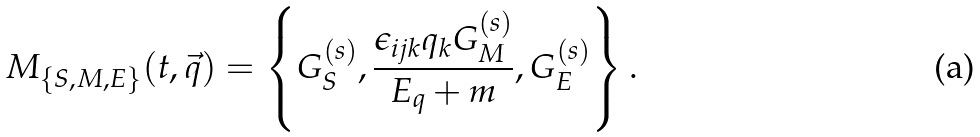Convert formula to latex. <formula><loc_0><loc_0><loc_500><loc_500>M _ { \{ S , M , E \} } ( t , \vec { q } ) = \left \{ G _ { S } ^ { ( s ) } , \frac { \epsilon _ { i j k } q _ { k } G _ { M } ^ { ( s ) } } { E _ { q } + m } , G _ { E } ^ { ( s ) } \right \} .</formula> 